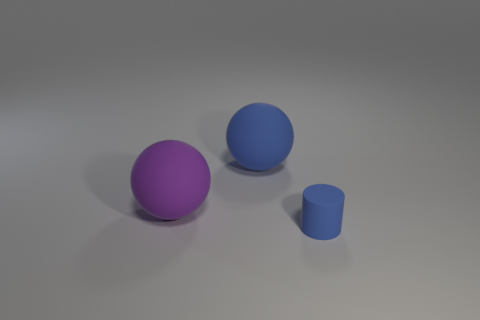What is the material of the small blue object? The small blue object appears to have a smooth, matte surface that could resemble rubber. However, based on the image alone, it's not possible to determine the material with certainty without physical inspection or additional context. 